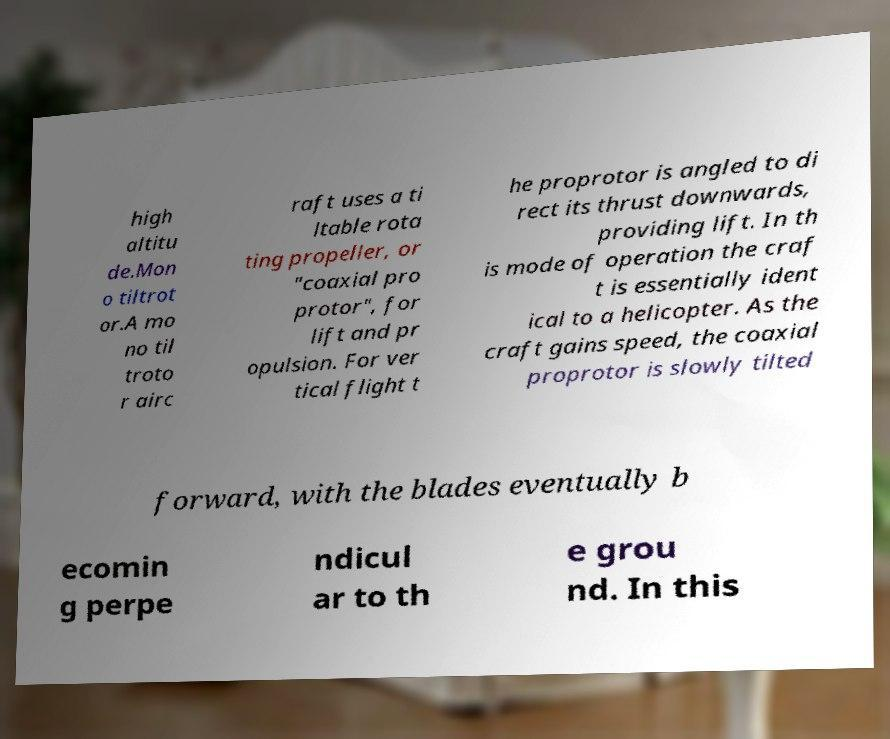I need the written content from this picture converted into text. Can you do that? high altitu de.Mon o tiltrot or.A mo no til troto r airc raft uses a ti ltable rota ting propeller, or "coaxial pro protor", for lift and pr opulsion. For ver tical flight t he proprotor is angled to di rect its thrust downwards, providing lift. In th is mode of operation the craf t is essentially ident ical to a helicopter. As the craft gains speed, the coaxial proprotor is slowly tilted forward, with the blades eventually b ecomin g perpe ndicul ar to th e grou nd. In this 